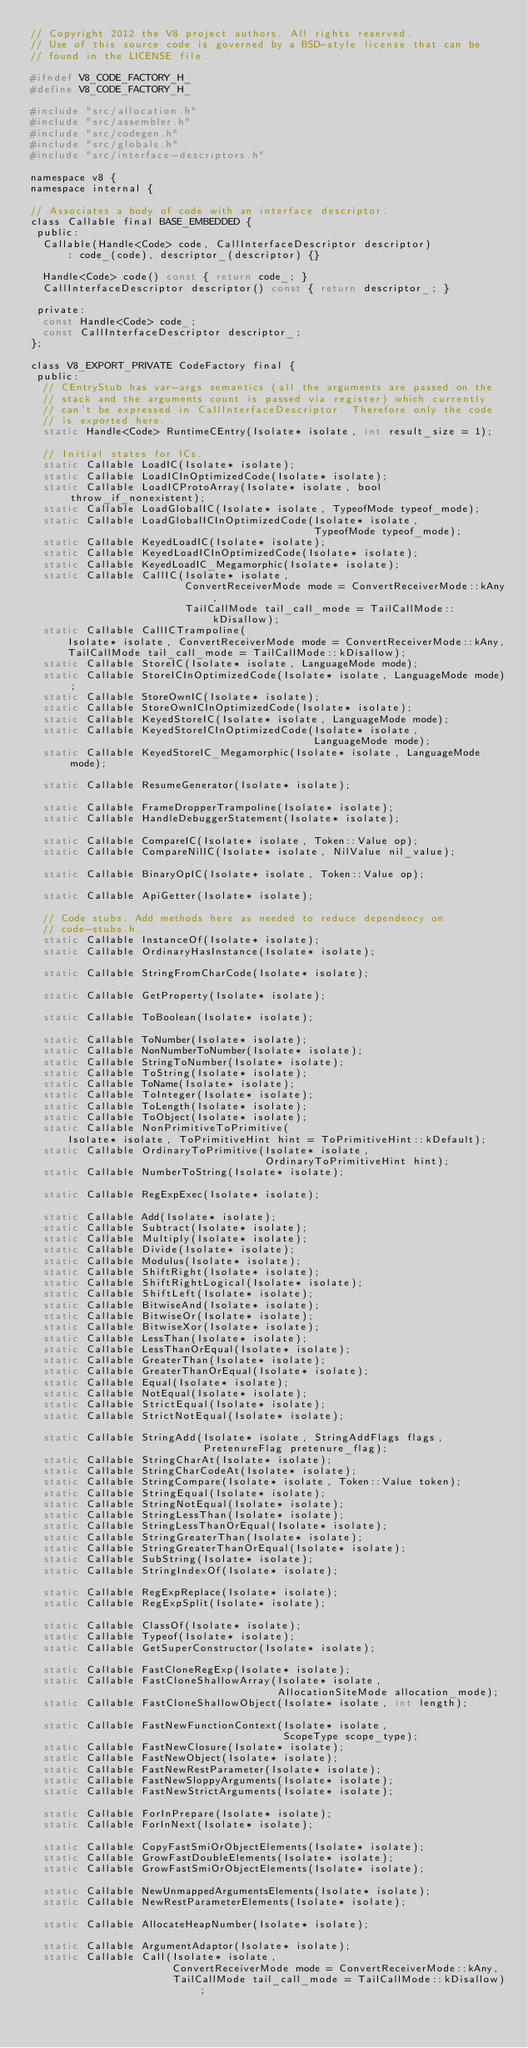Convert code to text. <code><loc_0><loc_0><loc_500><loc_500><_C_>// Copyright 2012 the V8 project authors. All rights reserved.
// Use of this source code is governed by a BSD-style license that can be
// found in the LICENSE file.

#ifndef V8_CODE_FACTORY_H_
#define V8_CODE_FACTORY_H_

#include "src/allocation.h"
#include "src/assembler.h"
#include "src/codegen.h"
#include "src/globals.h"
#include "src/interface-descriptors.h"

namespace v8 {
namespace internal {

// Associates a body of code with an interface descriptor.
class Callable final BASE_EMBEDDED {
 public:
  Callable(Handle<Code> code, CallInterfaceDescriptor descriptor)
      : code_(code), descriptor_(descriptor) {}

  Handle<Code> code() const { return code_; }
  CallInterfaceDescriptor descriptor() const { return descriptor_; }

 private:
  const Handle<Code> code_;
  const CallInterfaceDescriptor descriptor_;
};

class V8_EXPORT_PRIVATE CodeFactory final {
 public:
  // CEntryStub has var-args semantics (all the arguments are passed on the
  // stack and the arguments count is passed via register) which currently
  // can't be expressed in CallInterfaceDescriptor. Therefore only the code
  // is exported here.
  static Handle<Code> RuntimeCEntry(Isolate* isolate, int result_size = 1);

  // Initial states for ICs.
  static Callable LoadIC(Isolate* isolate);
  static Callable LoadICInOptimizedCode(Isolate* isolate);
  static Callable LoadICProtoArray(Isolate* isolate, bool throw_if_nonexistent);
  static Callable LoadGlobalIC(Isolate* isolate, TypeofMode typeof_mode);
  static Callable LoadGlobalICInOptimizedCode(Isolate* isolate,
                                              TypeofMode typeof_mode);
  static Callable KeyedLoadIC(Isolate* isolate);
  static Callable KeyedLoadICInOptimizedCode(Isolate* isolate);
  static Callable KeyedLoadIC_Megamorphic(Isolate* isolate);
  static Callable CallIC(Isolate* isolate,
                         ConvertReceiverMode mode = ConvertReceiverMode::kAny,
                         TailCallMode tail_call_mode = TailCallMode::kDisallow);
  static Callable CallICTrampoline(
      Isolate* isolate, ConvertReceiverMode mode = ConvertReceiverMode::kAny,
      TailCallMode tail_call_mode = TailCallMode::kDisallow);
  static Callable StoreIC(Isolate* isolate, LanguageMode mode);
  static Callable StoreICInOptimizedCode(Isolate* isolate, LanguageMode mode);
  static Callable StoreOwnIC(Isolate* isolate);
  static Callable StoreOwnICInOptimizedCode(Isolate* isolate);
  static Callable KeyedStoreIC(Isolate* isolate, LanguageMode mode);
  static Callable KeyedStoreICInOptimizedCode(Isolate* isolate,
                                              LanguageMode mode);
  static Callable KeyedStoreIC_Megamorphic(Isolate* isolate, LanguageMode mode);

  static Callable ResumeGenerator(Isolate* isolate);

  static Callable FrameDropperTrampoline(Isolate* isolate);
  static Callable HandleDebuggerStatement(Isolate* isolate);

  static Callable CompareIC(Isolate* isolate, Token::Value op);
  static Callable CompareNilIC(Isolate* isolate, NilValue nil_value);

  static Callable BinaryOpIC(Isolate* isolate, Token::Value op);

  static Callable ApiGetter(Isolate* isolate);

  // Code stubs. Add methods here as needed to reduce dependency on
  // code-stubs.h.
  static Callable InstanceOf(Isolate* isolate);
  static Callable OrdinaryHasInstance(Isolate* isolate);

  static Callable StringFromCharCode(Isolate* isolate);

  static Callable GetProperty(Isolate* isolate);

  static Callable ToBoolean(Isolate* isolate);

  static Callable ToNumber(Isolate* isolate);
  static Callable NonNumberToNumber(Isolate* isolate);
  static Callable StringToNumber(Isolate* isolate);
  static Callable ToString(Isolate* isolate);
  static Callable ToName(Isolate* isolate);
  static Callable ToInteger(Isolate* isolate);
  static Callable ToLength(Isolate* isolate);
  static Callable ToObject(Isolate* isolate);
  static Callable NonPrimitiveToPrimitive(
      Isolate* isolate, ToPrimitiveHint hint = ToPrimitiveHint::kDefault);
  static Callable OrdinaryToPrimitive(Isolate* isolate,
                                      OrdinaryToPrimitiveHint hint);
  static Callable NumberToString(Isolate* isolate);

  static Callable RegExpExec(Isolate* isolate);

  static Callable Add(Isolate* isolate);
  static Callable Subtract(Isolate* isolate);
  static Callable Multiply(Isolate* isolate);
  static Callable Divide(Isolate* isolate);
  static Callable Modulus(Isolate* isolate);
  static Callable ShiftRight(Isolate* isolate);
  static Callable ShiftRightLogical(Isolate* isolate);
  static Callable ShiftLeft(Isolate* isolate);
  static Callable BitwiseAnd(Isolate* isolate);
  static Callable BitwiseOr(Isolate* isolate);
  static Callable BitwiseXor(Isolate* isolate);
  static Callable LessThan(Isolate* isolate);
  static Callable LessThanOrEqual(Isolate* isolate);
  static Callable GreaterThan(Isolate* isolate);
  static Callable GreaterThanOrEqual(Isolate* isolate);
  static Callable Equal(Isolate* isolate);
  static Callable NotEqual(Isolate* isolate);
  static Callable StrictEqual(Isolate* isolate);
  static Callable StrictNotEqual(Isolate* isolate);

  static Callable StringAdd(Isolate* isolate, StringAddFlags flags,
                            PretenureFlag pretenure_flag);
  static Callable StringCharAt(Isolate* isolate);
  static Callable StringCharCodeAt(Isolate* isolate);
  static Callable StringCompare(Isolate* isolate, Token::Value token);
  static Callable StringEqual(Isolate* isolate);
  static Callable StringNotEqual(Isolate* isolate);
  static Callable StringLessThan(Isolate* isolate);
  static Callable StringLessThanOrEqual(Isolate* isolate);
  static Callable StringGreaterThan(Isolate* isolate);
  static Callable StringGreaterThanOrEqual(Isolate* isolate);
  static Callable SubString(Isolate* isolate);
  static Callable StringIndexOf(Isolate* isolate);

  static Callable RegExpReplace(Isolate* isolate);
  static Callable RegExpSplit(Isolate* isolate);

  static Callable ClassOf(Isolate* isolate);
  static Callable Typeof(Isolate* isolate);
  static Callable GetSuperConstructor(Isolate* isolate);

  static Callable FastCloneRegExp(Isolate* isolate);
  static Callable FastCloneShallowArray(Isolate* isolate,
                                        AllocationSiteMode allocation_mode);
  static Callable FastCloneShallowObject(Isolate* isolate, int length);

  static Callable FastNewFunctionContext(Isolate* isolate,
                                         ScopeType scope_type);
  static Callable FastNewClosure(Isolate* isolate);
  static Callable FastNewObject(Isolate* isolate);
  static Callable FastNewRestParameter(Isolate* isolate);
  static Callable FastNewSloppyArguments(Isolate* isolate);
  static Callable FastNewStrictArguments(Isolate* isolate);

  static Callable ForInPrepare(Isolate* isolate);
  static Callable ForInNext(Isolate* isolate);

  static Callable CopyFastSmiOrObjectElements(Isolate* isolate);
  static Callable GrowFastDoubleElements(Isolate* isolate);
  static Callable GrowFastSmiOrObjectElements(Isolate* isolate);

  static Callable NewUnmappedArgumentsElements(Isolate* isolate);
  static Callable NewRestParameterElements(Isolate* isolate);

  static Callable AllocateHeapNumber(Isolate* isolate);

  static Callable ArgumentAdaptor(Isolate* isolate);
  static Callable Call(Isolate* isolate,
                       ConvertReceiverMode mode = ConvertReceiverMode::kAny,
                       TailCallMode tail_call_mode = TailCallMode::kDisallow);</code> 